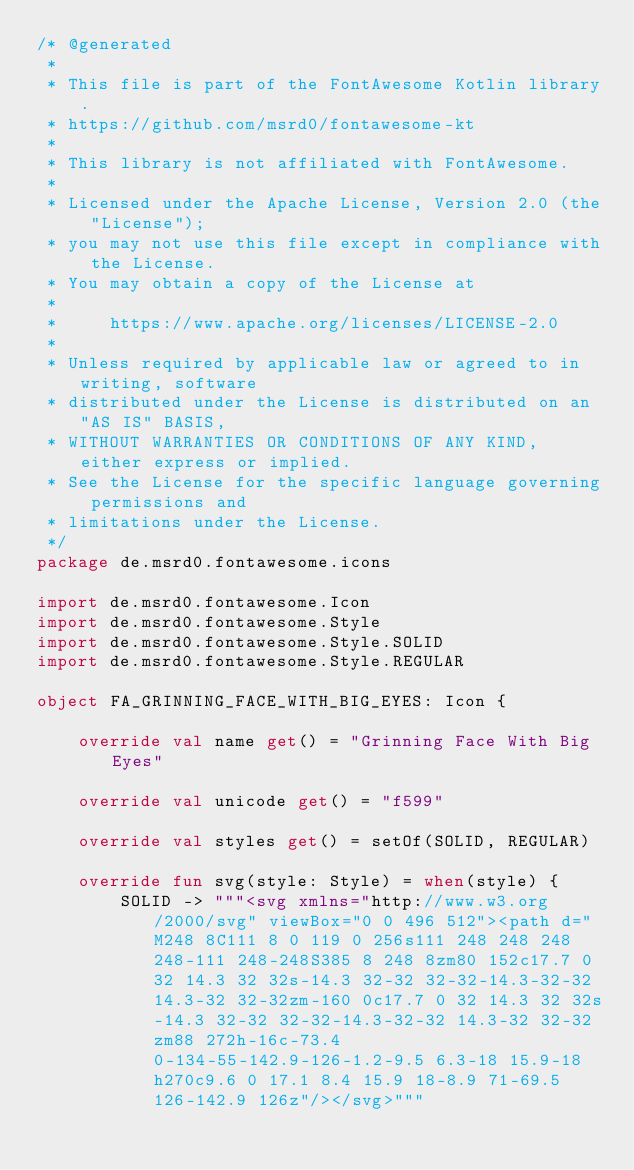<code> <loc_0><loc_0><loc_500><loc_500><_Kotlin_>/* @generated
 *
 * This file is part of the FontAwesome Kotlin library.
 * https://github.com/msrd0/fontawesome-kt
 *
 * This library is not affiliated with FontAwesome. 
 *
 * Licensed under the Apache License, Version 2.0 (the "License");
 * you may not use this file except in compliance with the License.
 * You may obtain a copy of the License at
 *
 *     https://www.apache.org/licenses/LICENSE-2.0
 *
 * Unless required by applicable law or agreed to in writing, software
 * distributed under the License is distributed on an "AS IS" BASIS,
 * WITHOUT WARRANTIES OR CONDITIONS OF ANY KIND, either express or implied.
 * See the License for the specific language governing permissions and
 * limitations under the License.
 */
package de.msrd0.fontawesome.icons

import de.msrd0.fontawesome.Icon
import de.msrd0.fontawesome.Style
import de.msrd0.fontawesome.Style.SOLID
import de.msrd0.fontawesome.Style.REGULAR

object FA_GRINNING_FACE_WITH_BIG_EYES: Icon {
	
	override val name get() = "Grinning Face With Big Eyes"
	
	override val unicode get() = "f599"
	
	override val styles get() = setOf(SOLID, REGULAR)
	
	override fun svg(style: Style) = when(style) {
		SOLID -> """<svg xmlns="http://www.w3.org/2000/svg" viewBox="0 0 496 512"><path d="M248 8C111 8 0 119 0 256s111 248 248 248 248-111 248-248S385 8 248 8zm80 152c17.7 0 32 14.3 32 32s-14.3 32-32 32-32-14.3-32-32 14.3-32 32-32zm-160 0c17.7 0 32 14.3 32 32s-14.3 32-32 32-32-14.3-32-32 14.3-32 32-32zm88 272h-16c-73.4 0-134-55-142.9-126-1.2-9.5 6.3-18 15.9-18h270c9.6 0 17.1 8.4 15.9 18-8.9 71-69.5 126-142.9 126z"/></svg>"""</code> 